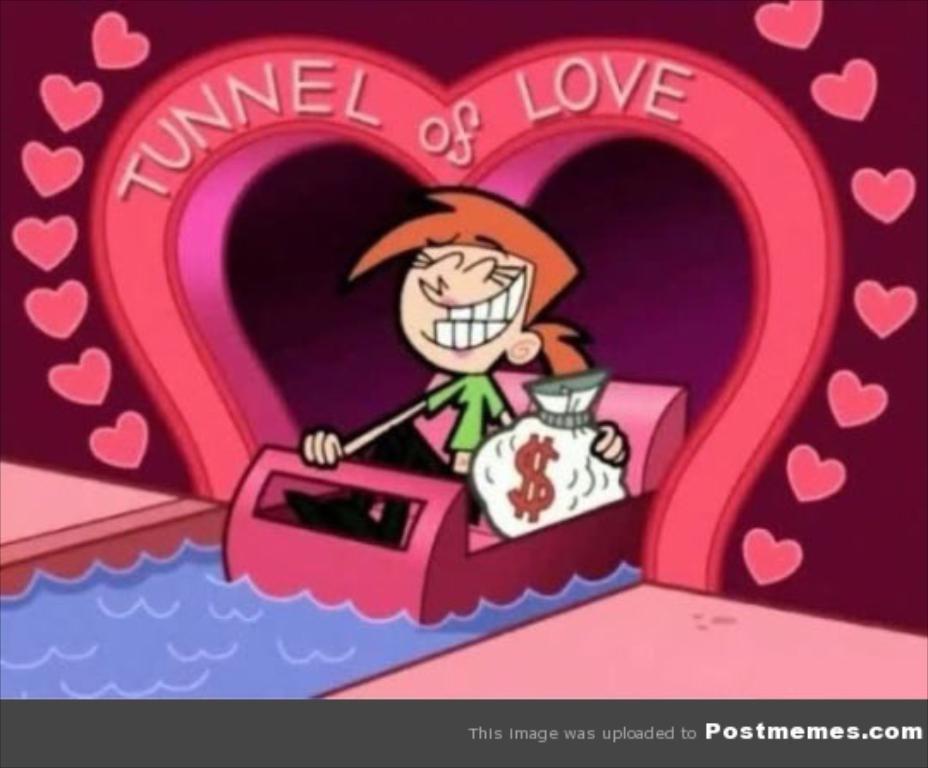Please provide a concise description of this image. In this picture we can observe a cartoon character. There is a person sitting in the pink color boat, holding a white color bag in their hand. Boat is floating on the water. We can observe maroon color wall and some heart symbols on the wall. The water is in blue color. 